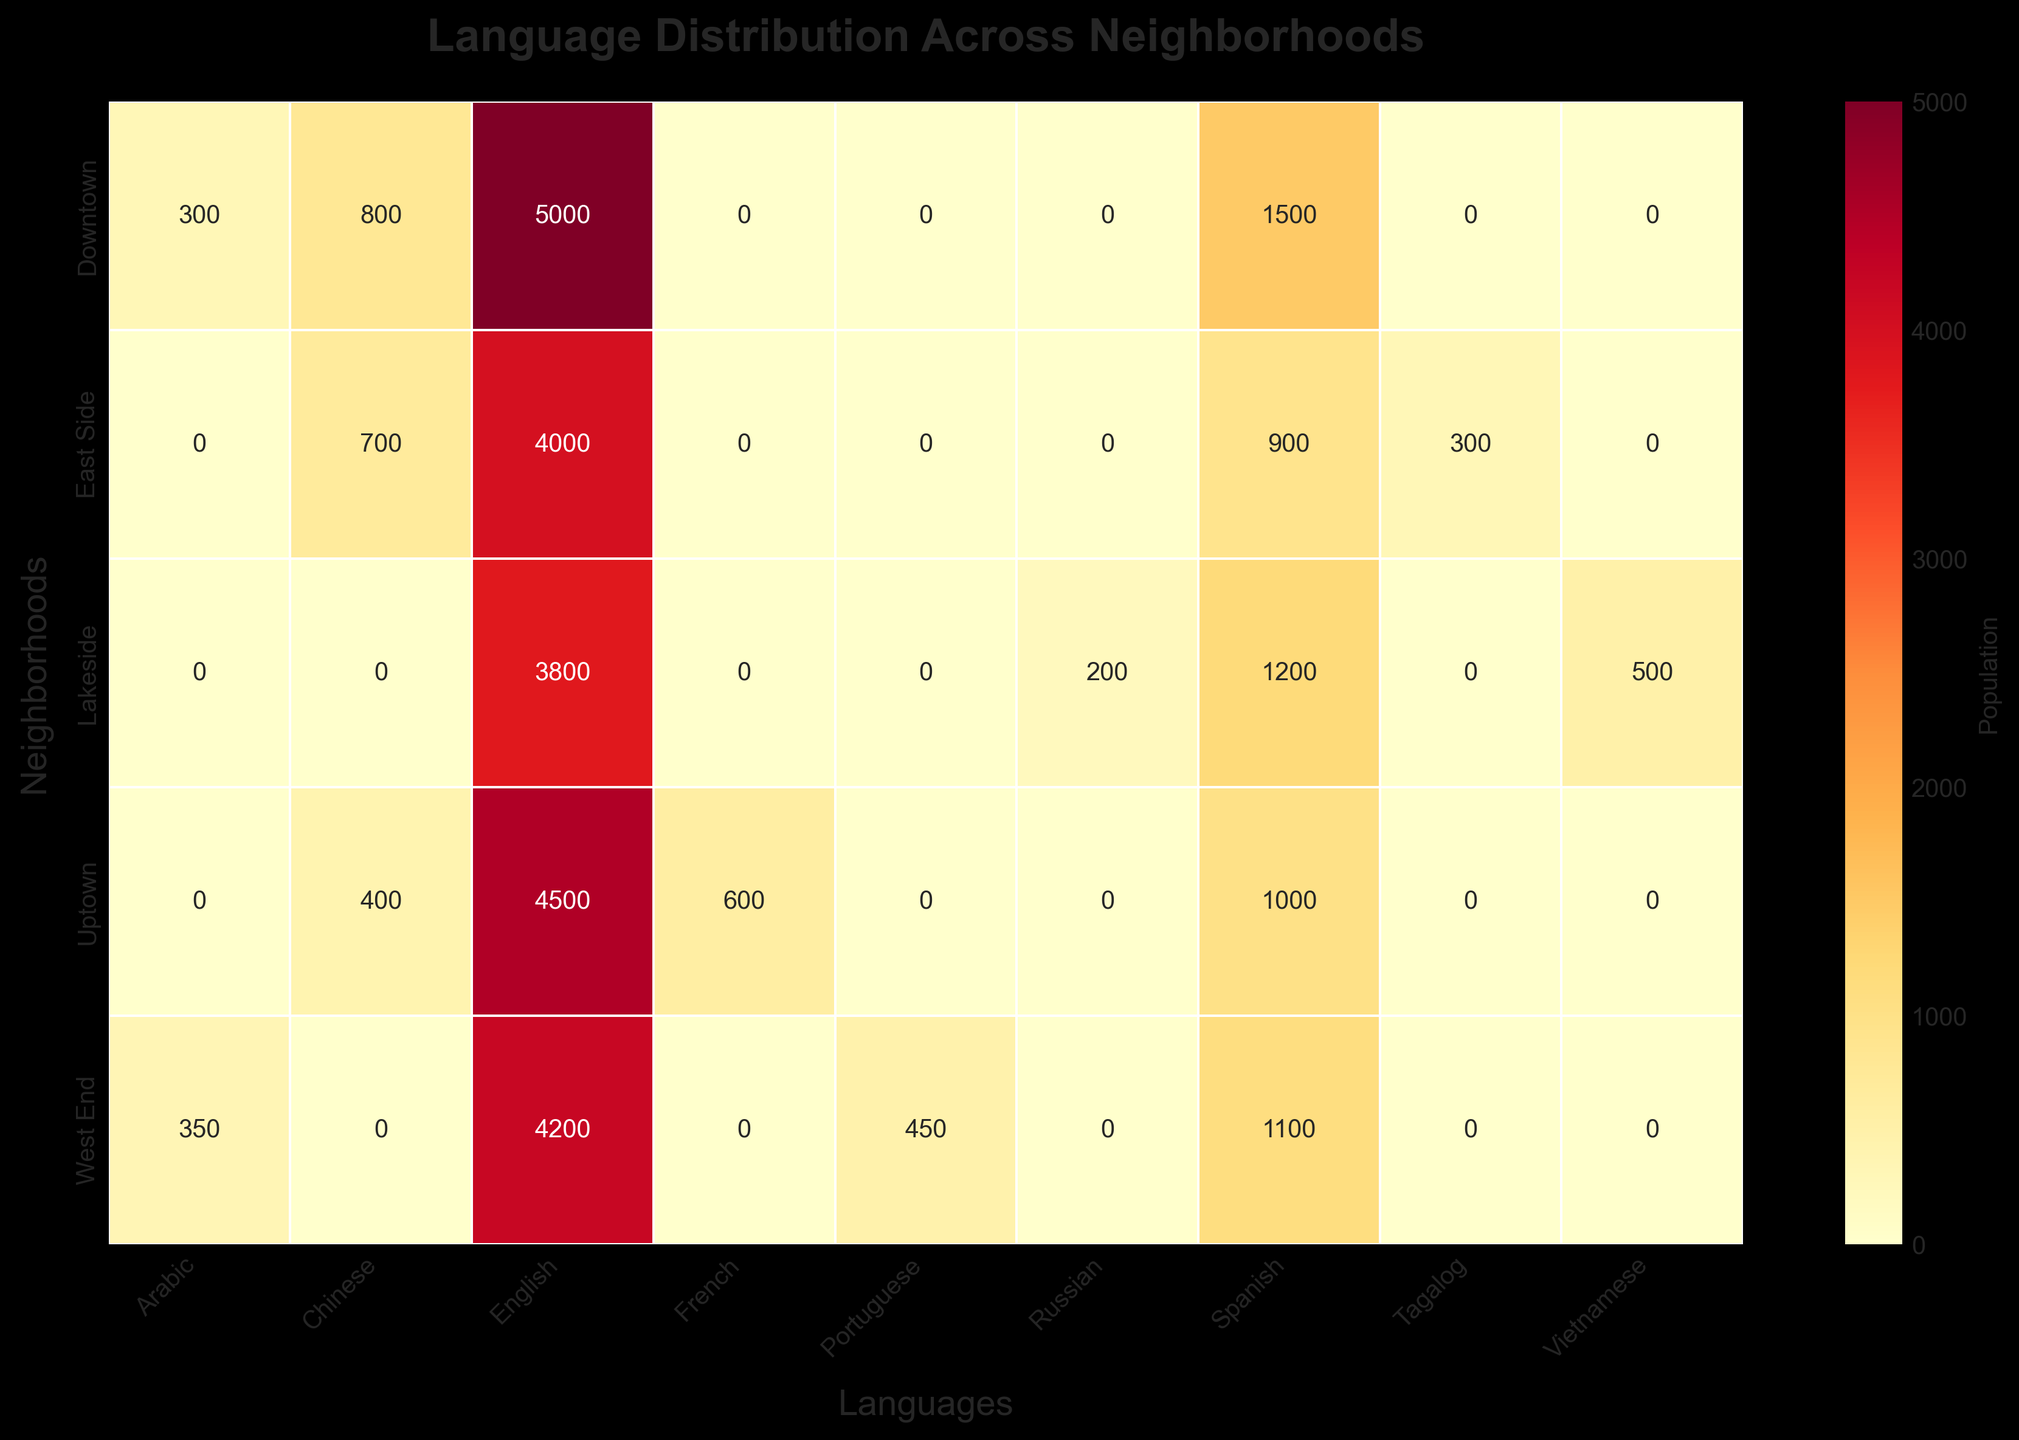Which neighborhood has the highest population of English speakers? To find the neighborhood with the highest population of English speakers, look for the maximum value in the "English" column. Downtown has 5000 English speakers, which is higher than Uptown with 4500, Lakeside with 3800, West End with 4200, and East Side with 4000.
Answer: Downtown What is the combined population of Chinese speakers in East Side and Uptown? To find the combined population, add the number of Chinese speakers in East Side (700) and Uptown (400). Performing the addition gives 700 + 400 = 1100.
Answer: 1100 Compare the number of Spanish speakers in Downtown and West End. Which neighborhood has more Spanish speakers? Compare the values in the "Spanish" column for Downtown and West End. Downtown has 1500 Spanish speakers and West End has 1100. 1500 is greater than 1100, so Downtown has more Spanish speakers.
Answer: Downtown Which language is spoken by the smallest population in Lakeside? Look at the values in the "Lakeside" row and find the smallest number. English has 3800, Spanish has 1200, Vietnamese has 500, and Russian has 200. The smallest population is Russian with 200.
Answer: Russian How does the Arabic-speaking population in Downtown compare to that in the West End? Examine the "Arabic" column for Downtown and West End. Downtown has 300 Arabic speakers whereas West End has 350. 350 is greater than 300, so West End has more Arabic speakers.
Answer: West End What is the total population of languages other than English in Downtown? Add the populations of Spanish, Chinese, and Arabic speakers in Downtown. This is 1500 (Spanish) + 800 (Chinese) + 300 (Arabic) = 2600.
Answer: 2600 Identify the neighborhood with the least diverse language population based on the figure. The least diverse neighborhood would have the fewest different languages represented. Check the figure for the number of languages in each neighborhood. Lakeside has 4 different languages (with the smallest total count), while the other neighborhoods also have 4. However, Lakeside's smallest total number of unique populations makes it the least diverse.
Answer: Lakeside What percentage of the Spanish-speaking population resides in Downtown? First, determine the total Spanish-speaking population across all neighborhoods: 1500 (Downtown) + 1000 (Uptown) + 1200 (Lakeside) + 1100 (West End) + 900 (East Side) = 5700. Then, calculate the percentage: (1500 / 5700) * 100 ≈ 26.32%.
Answer: 26.32% How does the population of French speakers in Uptown compare to Russian speakers in Lakeside? Uptown has 600 French speakers while Lakeside has 200 Russian speakers. 600 is greater than 200, so Uptown has more French speakers compared to Russian speakers in Lakeside.
Answer: Uptown 